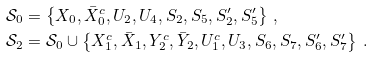Convert formula to latex. <formula><loc_0><loc_0><loc_500><loc_500>\mathcal { S } _ { 0 } & = \left \{ X _ { 0 } , \bar { X } ^ { c } _ { 0 } , U _ { 2 } , U _ { 4 } , S _ { 2 } , S _ { 5 } , S _ { 2 } ^ { \prime } , S _ { 5 } ^ { \prime } \right \} \, , \\ \mathcal { S } _ { 2 } & = \mathcal { S } _ { 0 } \cup \left \{ X _ { 1 } ^ { c } , \bar { X } _ { 1 } , Y _ { 2 } ^ { c } , \bar { Y } _ { 2 } , U _ { 1 } ^ { c } , U _ { 3 } , S _ { 6 } , S _ { 7 } , S _ { 6 } ^ { \prime } , S _ { 7 } ^ { \prime } \right \} \, .</formula> 